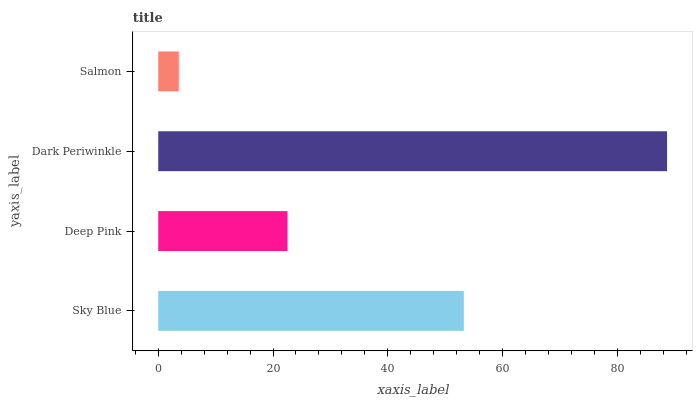Is Salmon the minimum?
Answer yes or no. Yes. Is Dark Periwinkle the maximum?
Answer yes or no. Yes. Is Deep Pink the minimum?
Answer yes or no. No. Is Deep Pink the maximum?
Answer yes or no. No. Is Sky Blue greater than Deep Pink?
Answer yes or no. Yes. Is Deep Pink less than Sky Blue?
Answer yes or no. Yes. Is Deep Pink greater than Sky Blue?
Answer yes or no. No. Is Sky Blue less than Deep Pink?
Answer yes or no. No. Is Sky Blue the high median?
Answer yes or no. Yes. Is Deep Pink the low median?
Answer yes or no. Yes. Is Dark Periwinkle the high median?
Answer yes or no. No. Is Dark Periwinkle the low median?
Answer yes or no. No. 